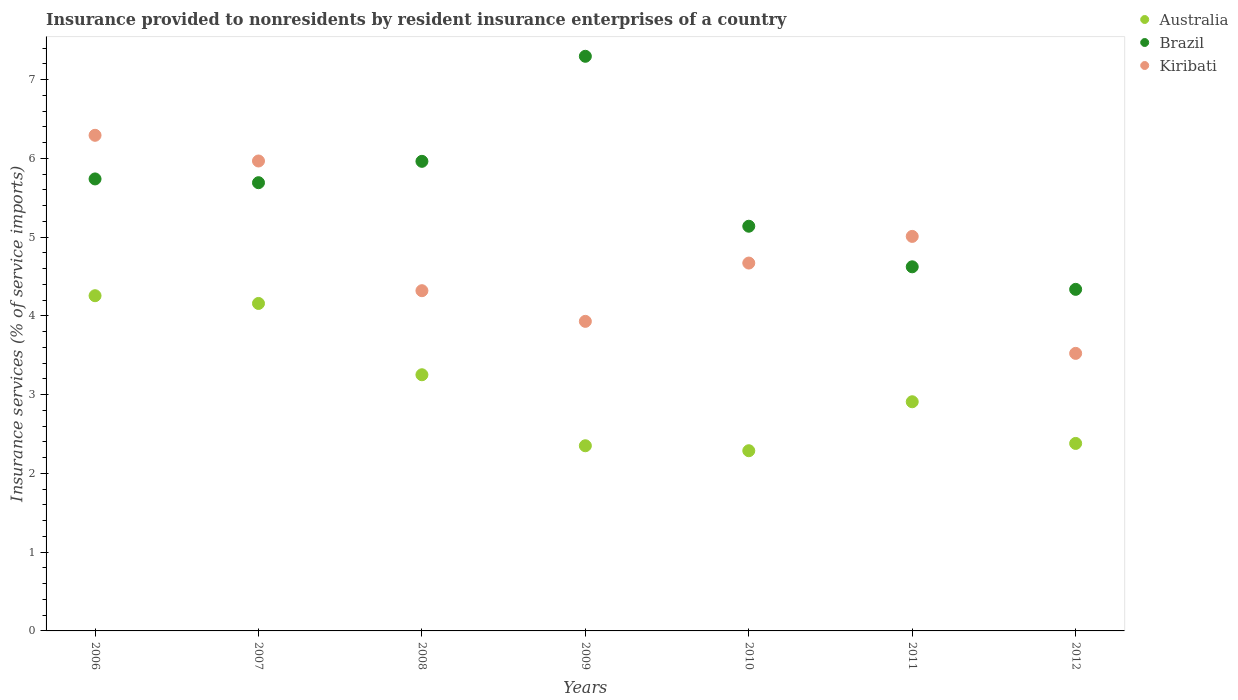How many different coloured dotlines are there?
Offer a terse response. 3. Is the number of dotlines equal to the number of legend labels?
Offer a terse response. Yes. What is the insurance provided to nonresidents in Brazil in 2010?
Offer a terse response. 5.14. Across all years, what is the maximum insurance provided to nonresidents in Brazil?
Provide a succinct answer. 7.3. Across all years, what is the minimum insurance provided to nonresidents in Brazil?
Your response must be concise. 4.34. In which year was the insurance provided to nonresidents in Brazil maximum?
Keep it short and to the point. 2009. In which year was the insurance provided to nonresidents in Kiribati minimum?
Give a very brief answer. 2012. What is the total insurance provided to nonresidents in Kiribati in the graph?
Offer a terse response. 33.71. What is the difference between the insurance provided to nonresidents in Australia in 2008 and that in 2009?
Offer a very short reply. 0.9. What is the difference between the insurance provided to nonresidents in Australia in 2006 and the insurance provided to nonresidents in Kiribati in 2007?
Your response must be concise. -1.71. What is the average insurance provided to nonresidents in Australia per year?
Your answer should be very brief. 3.08. In the year 2006, what is the difference between the insurance provided to nonresidents in Kiribati and insurance provided to nonresidents in Brazil?
Keep it short and to the point. 0.55. In how many years, is the insurance provided to nonresidents in Australia greater than 1.6 %?
Ensure brevity in your answer.  7. What is the ratio of the insurance provided to nonresidents in Brazil in 2006 to that in 2012?
Give a very brief answer. 1.32. Is the insurance provided to nonresidents in Kiribati in 2006 less than that in 2011?
Provide a succinct answer. No. Is the difference between the insurance provided to nonresidents in Kiribati in 2008 and 2010 greater than the difference between the insurance provided to nonresidents in Brazil in 2008 and 2010?
Offer a very short reply. No. What is the difference between the highest and the second highest insurance provided to nonresidents in Australia?
Your answer should be very brief. 0.1. What is the difference between the highest and the lowest insurance provided to nonresidents in Australia?
Ensure brevity in your answer.  1.97. In how many years, is the insurance provided to nonresidents in Australia greater than the average insurance provided to nonresidents in Australia taken over all years?
Your answer should be very brief. 3. Does the insurance provided to nonresidents in Kiribati monotonically increase over the years?
Provide a short and direct response. No. Is the insurance provided to nonresidents in Australia strictly less than the insurance provided to nonresidents in Kiribati over the years?
Your answer should be compact. Yes. How many years are there in the graph?
Provide a succinct answer. 7. What is the difference between two consecutive major ticks on the Y-axis?
Your answer should be compact. 1. Does the graph contain grids?
Provide a short and direct response. No. How many legend labels are there?
Make the answer very short. 3. How are the legend labels stacked?
Provide a short and direct response. Vertical. What is the title of the graph?
Ensure brevity in your answer.  Insurance provided to nonresidents by resident insurance enterprises of a country. Does "Tonga" appear as one of the legend labels in the graph?
Provide a short and direct response. No. What is the label or title of the X-axis?
Provide a succinct answer. Years. What is the label or title of the Y-axis?
Offer a terse response. Insurance services (% of service imports). What is the Insurance services (% of service imports) of Australia in 2006?
Make the answer very short. 4.26. What is the Insurance services (% of service imports) of Brazil in 2006?
Ensure brevity in your answer.  5.74. What is the Insurance services (% of service imports) in Kiribati in 2006?
Provide a short and direct response. 6.29. What is the Insurance services (% of service imports) of Australia in 2007?
Your response must be concise. 4.16. What is the Insurance services (% of service imports) in Brazil in 2007?
Offer a very short reply. 5.69. What is the Insurance services (% of service imports) of Kiribati in 2007?
Ensure brevity in your answer.  5.97. What is the Insurance services (% of service imports) of Australia in 2008?
Offer a very short reply. 3.25. What is the Insurance services (% of service imports) of Brazil in 2008?
Give a very brief answer. 5.96. What is the Insurance services (% of service imports) of Kiribati in 2008?
Keep it short and to the point. 4.32. What is the Insurance services (% of service imports) in Australia in 2009?
Ensure brevity in your answer.  2.35. What is the Insurance services (% of service imports) in Brazil in 2009?
Offer a very short reply. 7.3. What is the Insurance services (% of service imports) in Kiribati in 2009?
Provide a succinct answer. 3.93. What is the Insurance services (% of service imports) of Australia in 2010?
Make the answer very short. 2.29. What is the Insurance services (% of service imports) in Brazil in 2010?
Ensure brevity in your answer.  5.14. What is the Insurance services (% of service imports) of Kiribati in 2010?
Offer a very short reply. 4.67. What is the Insurance services (% of service imports) in Australia in 2011?
Offer a terse response. 2.91. What is the Insurance services (% of service imports) of Brazil in 2011?
Provide a short and direct response. 4.62. What is the Insurance services (% of service imports) of Kiribati in 2011?
Your answer should be very brief. 5.01. What is the Insurance services (% of service imports) in Australia in 2012?
Provide a short and direct response. 2.38. What is the Insurance services (% of service imports) in Brazil in 2012?
Give a very brief answer. 4.34. What is the Insurance services (% of service imports) in Kiribati in 2012?
Your answer should be very brief. 3.52. Across all years, what is the maximum Insurance services (% of service imports) in Australia?
Ensure brevity in your answer.  4.26. Across all years, what is the maximum Insurance services (% of service imports) in Brazil?
Give a very brief answer. 7.3. Across all years, what is the maximum Insurance services (% of service imports) in Kiribati?
Ensure brevity in your answer.  6.29. Across all years, what is the minimum Insurance services (% of service imports) in Australia?
Your answer should be compact. 2.29. Across all years, what is the minimum Insurance services (% of service imports) of Brazil?
Provide a succinct answer. 4.34. Across all years, what is the minimum Insurance services (% of service imports) in Kiribati?
Ensure brevity in your answer.  3.52. What is the total Insurance services (% of service imports) of Australia in the graph?
Give a very brief answer. 21.59. What is the total Insurance services (% of service imports) in Brazil in the graph?
Offer a terse response. 38.78. What is the total Insurance services (% of service imports) in Kiribati in the graph?
Your response must be concise. 33.71. What is the difference between the Insurance services (% of service imports) in Australia in 2006 and that in 2007?
Your response must be concise. 0.1. What is the difference between the Insurance services (% of service imports) in Brazil in 2006 and that in 2007?
Make the answer very short. 0.05. What is the difference between the Insurance services (% of service imports) in Kiribati in 2006 and that in 2007?
Offer a terse response. 0.33. What is the difference between the Insurance services (% of service imports) of Brazil in 2006 and that in 2008?
Offer a terse response. -0.22. What is the difference between the Insurance services (% of service imports) in Kiribati in 2006 and that in 2008?
Give a very brief answer. 1.97. What is the difference between the Insurance services (% of service imports) in Australia in 2006 and that in 2009?
Your response must be concise. 1.9. What is the difference between the Insurance services (% of service imports) of Brazil in 2006 and that in 2009?
Your answer should be very brief. -1.56. What is the difference between the Insurance services (% of service imports) of Kiribati in 2006 and that in 2009?
Your answer should be very brief. 2.36. What is the difference between the Insurance services (% of service imports) of Australia in 2006 and that in 2010?
Give a very brief answer. 1.97. What is the difference between the Insurance services (% of service imports) of Brazil in 2006 and that in 2010?
Your answer should be compact. 0.6. What is the difference between the Insurance services (% of service imports) of Kiribati in 2006 and that in 2010?
Your answer should be very brief. 1.62. What is the difference between the Insurance services (% of service imports) in Australia in 2006 and that in 2011?
Provide a short and direct response. 1.35. What is the difference between the Insurance services (% of service imports) in Brazil in 2006 and that in 2011?
Give a very brief answer. 1.12. What is the difference between the Insurance services (% of service imports) of Kiribati in 2006 and that in 2011?
Provide a succinct answer. 1.28. What is the difference between the Insurance services (% of service imports) of Australia in 2006 and that in 2012?
Ensure brevity in your answer.  1.88. What is the difference between the Insurance services (% of service imports) of Brazil in 2006 and that in 2012?
Your response must be concise. 1.4. What is the difference between the Insurance services (% of service imports) of Kiribati in 2006 and that in 2012?
Your answer should be compact. 2.77. What is the difference between the Insurance services (% of service imports) in Australia in 2007 and that in 2008?
Offer a very short reply. 0.91. What is the difference between the Insurance services (% of service imports) of Brazil in 2007 and that in 2008?
Provide a succinct answer. -0.27. What is the difference between the Insurance services (% of service imports) of Kiribati in 2007 and that in 2008?
Provide a short and direct response. 1.65. What is the difference between the Insurance services (% of service imports) in Australia in 2007 and that in 2009?
Offer a very short reply. 1.81. What is the difference between the Insurance services (% of service imports) in Brazil in 2007 and that in 2009?
Offer a terse response. -1.6. What is the difference between the Insurance services (% of service imports) of Kiribati in 2007 and that in 2009?
Provide a succinct answer. 2.04. What is the difference between the Insurance services (% of service imports) in Australia in 2007 and that in 2010?
Offer a very short reply. 1.87. What is the difference between the Insurance services (% of service imports) in Brazil in 2007 and that in 2010?
Offer a very short reply. 0.55. What is the difference between the Insurance services (% of service imports) in Kiribati in 2007 and that in 2010?
Your answer should be very brief. 1.3. What is the difference between the Insurance services (% of service imports) in Australia in 2007 and that in 2011?
Your answer should be compact. 1.25. What is the difference between the Insurance services (% of service imports) of Brazil in 2007 and that in 2011?
Give a very brief answer. 1.07. What is the difference between the Insurance services (% of service imports) in Kiribati in 2007 and that in 2011?
Offer a very short reply. 0.96. What is the difference between the Insurance services (% of service imports) of Australia in 2007 and that in 2012?
Offer a terse response. 1.78. What is the difference between the Insurance services (% of service imports) of Brazil in 2007 and that in 2012?
Make the answer very short. 1.35. What is the difference between the Insurance services (% of service imports) in Kiribati in 2007 and that in 2012?
Keep it short and to the point. 2.44. What is the difference between the Insurance services (% of service imports) in Australia in 2008 and that in 2009?
Keep it short and to the point. 0.9. What is the difference between the Insurance services (% of service imports) in Brazil in 2008 and that in 2009?
Make the answer very short. -1.33. What is the difference between the Insurance services (% of service imports) in Kiribati in 2008 and that in 2009?
Your answer should be very brief. 0.39. What is the difference between the Insurance services (% of service imports) in Australia in 2008 and that in 2010?
Ensure brevity in your answer.  0.96. What is the difference between the Insurance services (% of service imports) of Brazil in 2008 and that in 2010?
Ensure brevity in your answer.  0.82. What is the difference between the Insurance services (% of service imports) of Kiribati in 2008 and that in 2010?
Ensure brevity in your answer.  -0.35. What is the difference between the Insurance services (% of service imports) of Australia in 2008 and that in 2011?
Provide a short and direct response. 0.34. What is the difference between the Insurance services (% of service imports) in Brazil in 2008 and that in 2011?
Keep it short and to the point. 1.34. What is the difference between the Insurance services (% of service imports) in Kiribati in 2008 and that in 2011?
Keep it short and to the point. -0.69. What is the difference between the Insurance services (% of service imports) of Australia in 2008 and that in 2012?
Offer a terse response. 0.87. What is the difference between the Insurance services (% of service imports) of Brazil in 2008 and that in 2012?
Give a very brief answer. 1.63. What is the difference between the Insurance services (% of service imports) of Kiribati in 2008 and that in 2012?
Your answer should be very brief. 0.8. What is the difference between the Insurance services (% of service imports) of Australia in 2009 and that in 2010?
Keep it short and to the point. 0.06. What is the difference between the Insurance services (% of service imports) in Brazil in 2009 and that in 2010?
Your answer should be compact. 2.16. What is the difference between the Insurance services (% of service imports) of Kiribati in 2009 and that in 2010?
Offer a very short reply. -0.74. What is the difference between the Insurance services (% of service imports) in Australia in 2009 and that in 2011?
Your response must be concise. -0.56. What is the difference between the Insurance services (% of service imports) in Brazil in 2009 and that in 2011?
Your answer should be very brief. 2.67. What is the difference between the Insurance services (% of service imports) in Kiribati in 2009 and that in 2011?
Keep it short and to the point. -1.08. What is the difference between the Insurance services (% of service imports) in Australia in 2009 and that in 2012?
Make the answer very short. -0.03. What is the difference between the Insurance services (% of service imports) in Brazil in 2009 and that in 2012?
Make the answer very short. 2.96. What is the difference between the Insurance services (% of service imports) in Kiribati in 2009 and that in 2012?
Give a very brief answer. 0.41. What is the difference between the Insurance services (% of service imports) of Australia in 2010 and that in 2011?
Offer a terse response. -0.62. What is the difference between the Insurance services (% of service imports) in Brazil in 2010 and that in 2011?
Make the answer very short. 0.52. What is the difference between the Insurance services (% of service imports) in Kiribati in 2010 and that in 2011?
Your answer should be compact. -0.34. What is the difference between the Insurance services (% of service imports) in Australia in 2010 and that in 2012?
Keep it short and to the point. -0.09. What is the difference between the Insurance services (% of service imports) in Brazil in 2010 and that in 2012?
Provide a short and direct response. 0.8. What is the difference between the Insurance services (% of service imports) in Kiribati in 2010 and that in 2012?
Your answer should be compact. 1.15. What is the difference between the Insurance services (% of service imports) in Australia in 2011 and that in 2012?
Give a very brief answer. 0.53. What is the difference between the Insurance services (% of service imports) in Brazil in 2011 and that in 2012?
Provide a succinct answer. 0.29. What is the difference between the Insurance services (% of service imports) of Kiribati in 2011 and that in 2012?
Your response must be concise. 1.48. What is the difference between the Insurance services (% of service imports) of Australia in 2006 and the Insurance services (% of service imports) of Brazil in 2007?
Make the answer very short. -1.43. What is the difference between the Insurance services (% of service imports) of Australia in 2006 and the Insurance services (% of service imports) of Kiribati in 2007?
Your answer should be compact. -1.71. What is the difference between the Insurance services (% of service imports) of Brazil in 2006 and the Insurance services (% of service imports) of Kiribati in 2007?
Your answer should be very brief. -0.23. What is the difference between the Insurance services (% of service imports) in Australia in 2006 and the Insurance services (% of service imports) in Brazil in 2008?
Make the answer very short. -1.71. What is the difference between the Insurance services (% of service imports) of Australia in 2006 and the Insurance services (% of service imports) of Kiribati in 2008?
Keep it short and to the point. -0.06. What is the difference between the Insurance services (% of service imports) of Brazil in 2006 and the Insurance services (% of service imports) of Kiribati in 2008?
Your answer should be very brief. 1.42. What is the difference between the Insurance services (% of service imports) in Australia in 2006 and the Insurance services (% of service imports) in Brazil in 2009?
Keep it short and to the point. -3.04. What is the difference between the Insurance services (% of service imports) in Australia in 2006 and the Insurance services (% of service imports) in Kiribati in 2009?
Your answer should be compact. 0.33. What is the difference between the Insurance services (% of service imports) in Brazil in 2006 and the Insurance services (% of service imports) in Kiribati in 2009?
Give a very brief answer. 1.81. What is the difference between the Insurance services (% of service imports) of Australia in 2006 and the Insurance services (% of service imports) of Brazil in 2010?
Your answer should be compact. -0.88. What is the difference between the Insurance services (% of service imports) of Australia in 2006 and the Insurance services (% of service imports) of Kiribati in 2010?
Provide a succinct answer. -0.41. What is the difference between the Insurance services (% of service imports) of Brazil in 2006 and the Insurance services (% of service imports) of Kiribati in 2010?
Offer a terse response. 1.07. What is the difference between the Insurance services (% of service imports) of Australia in 2006 and the Insurance services (% of service imports) of Brazil in 2011?
Provide a short and direct response. -0.37. What is the difference between the Insurance services (% of service imports) in Australia in 2006 and the Insurance services (% of service imports) in Kiribati in 2011?
Give a very brief answer. -0.75. What is the difference between the Insurance services (% of service imports) of Brazil in 2006 and the Insurance services (% of service imports) of Kiribati in 2011?
Keep it short and to the point. 0.73. What is the difference between the Insurance services (% of service imports) in Australia in 2006 and the Insurance services (% of service imports) in Brazil in 2012?
Offer a very short reply. -0.08. What is the difference between the Insurance services (% of service imports) in Australia in 2006 and the Insurance services (% of service imports) in Kiribati in 2012?
Your answer should be compact. 0.73. What is the difference between the Insurance services (% of service imports) of Brazil in 2006 and the Insurance services (% of service imports) of Kiribati in 2012?
Offer a terse response. 2.21. What is the difference between the Insurance services (% of service imports) of Australia in 2007 and the Insurance services (% of service imports) of Brazil in 2008?
Give a very brief answer. -1.8. What is the difference between the Insurance services (% of service imports) in Australia in 2007 and the Insurance services (% of service imports) in Kiribati in 2008?
Offer a very short reply. -0.16. What is the difference between the Insurance services (% of service imports) of Brazil in 2007 and the Insurance services (% of service imports) of Kiribati in 2008?
Your response must be concise. 1.37. What is the difference between the Insurance services (% of service imports) of Australia in 2007 and the Insurance services (% of service imports) of Brazil in 2009?
Make the answer very short. -3.14. What is the difference between the Insurance services (% of service imports) in Australia in 2007 and the Insurance services (% of service imports) in Kiribati in 2009?
Ensure brevity in your answer.  0.23. What is the difference between the Insurance services (% of service imports) of Brazil in 2007 and the Insurance services (% of service imports) of Kiribati in 2009?
Make the answer very short. 1.76. What is the difference between the Insurance services (% of service imports) in Australia in 2007 and the Insurance services (% of service imports) in Brazil in 2010?
Provide a succinct answer. -0.98. What is the difference between the Insurance services (% of service imports) in Australia in 2007 and the Insurance services (% of service imports) in Kiribati in 2010?
Make the answer very short. -0.51. What is the difference between the Insurance services (% of service imports) in Brazil in 2007 and the Insurance services (% of service imports) in Kiribati in 2010?
Give a very brief answer. 1.02. What is the difference between the Insurance services (% of service imports) of Australia in 2007 and the Insurance services (% of service imports) of Brazil in 2011?
Make the answer very short. -0.47. What is the difference between the Insurance services (% of service imports) of Australia in 2007 and the Insurance services (% of service imports) of Kiribati in 2011?
Your answer should be compact. -0.85. What is the difference between the Insurance services (% of service imports) in Brazil in 2007 and the Insurance services (% of service imports) in Kiribati in 2011?
Your answer should be very brief. 0.68. What is the difference between the Insurance services (% of service imports) in Australia in 2007 and the Insurance services (% of service imports) in Brazil in 2012?
Ensure brevity in your answer.  -0.18. What is the difference between the Insurance services (% of service imports) in Australia in 2007 and the Insurance services (% of service imports) in Kiribati in 2012?
Provide a succinct answer. 0.63. What is the difference between the Insurance services (% of service imports) of Brazil in 2007 and the Insurance services (% of service imports) of Kiribati in 2012?
Your answer should be very brief. 2.17. What is the difference between the Insurance services (% of service imports) in Australia in 2008 and the Insurance services (% of service imports) in Brazil in 2009?
Your answer should be very brief. -4.04. What is the difference between the Insurance services (% of service imports) of Australia in 2008 and the Insurance services (% of service imports) of Kiribati in 2009?
Ensure brevity in your answer.  -0.68. What is the difference between the Insurance services (% of service imports) in Brazil in 2008 and the Insurance services (% of service imports) in Kiribati in 2009?
Keep it short and to the point. 2.03. What is the difference between the Insurance services (% of service imports) in Australia in 2008 and the Insurance services (% of service imports) in Brazil in 2010?
Ensure brevity in your answer.  -1.89. What is the difference between the Insurance services (% of service imports) of Australia in 2008 and the Insurance services (% of service imports) of Kiribati in 2010?
Offer a very short reply. -1.42. What is the difference between the Insurance services (% of service imports) of Brazil in 2008 and the Insurance services (% of service imports) of Kiribati in 2010?
Provide a short and direct response. 1.29. What is the difference between the Insurance services (% of service imports) in Australia in 2008 and the Insurance services (% of service imports) in Brazil in 2011?
Keep it short and to the point. -1.37. What is the difference between the Insurance services (% of service imports) of Australia in 2008 and the Insurance services (% of service imports) of Kiribati in 2011?
Offer a very short reply. -1.76. What is the difference between the Insurance services (% of service imports) of Brazil in 2008 and the Insurance services (% of service imports) of Kiribati in 2011?
Your answer should be compact. 0.95. What is the difference between the Insurance services (% of service imports) in Australia in 2008 and the Insurance services (% of service imports) in Brazil in 2012?
Make the answer very short. -1.08. What is the difference between the Insurance services (% of service imports) in Australia in 2008 and the Insurance services (% of service imports) in Kiribati in 2012?
Provide a succinct answer. -0.27. What is the difference between the Insurance services (% of service imports) of Brazil in 2008 and the Insurance services (% of service imports) of Kiribati in 2012?
Keep it short and to the point. 2.44. What is the difference between the Insurance services (% of service imports) of Australia in 2009 and the Insurance services (% of service imports) of Brazil in 2010?
Your answer should be compact. -2.79. What is the difference between the Insurance services (% of service imports) of Australia in 2009 and the Insurance services (% of service imports) of Kiribati in 2010?
Make the answer very short. -2.32. What is the difference between the Insurance services (% of service imports) of Brazil in 2009 and the Insurance services (% of service imports) of Kiribati in 2010?
Your answer should be very brief. 2.62. What is the difference between the Insurance services (% of service imports) of Australia in 2009 and the Insurance services (% of service imports) of Brazil in 2011?
Offer a terse response. -2.27. What is the difference between the Insurance services (% of service imports) of Australia in 2009 and the Insurance services (% of service imports) of Kiribati in 2011?
Keep it short and to the point. -2.66. What is the difference between the Insurance services (% of service imports) of Brazil in 2009 and the Insurance services (% of service imports) of Kiribati in 2011?
Offer a terse response. 2.29. What is the difference between the Insurance services (% of service imports) of Australia in 2009 and the Insurance services (% of service imports) of Brazil in 2012?
Provide a succinct answer. -1.99. What is the difference between the Insurance services (% of service imports) of Australia in 2009 and the Insurance services (% of service imports) of Kiribati in 2012?
Your response must be concise. -1.17. What is the difference between the Insurance services (% of service imports) of Brazil in 2009 and the Insurance services (% of service imports) of Kiribati in 2012?
Your response must be concise. 3.77. What is the difference between the Insurance services (% of service imports) in Australia in 2010 and the Insurance services (% of service imports) in Brazil in 2011?
Give a very brief answer. -2.33. What is the difference between the Insurance services (% of service imports) in Australia in 2010 and the Insurance services (% of service imports) in Kiribati in 2011?
Keep it short and to the point. -2.72. What is the difference between the Insurance services (% of service imports) in Brazil in 2010 and the Insurance services (% of service imports) in Kiribati in 2011?
Provide a short and direct response. 0.13. What is the difference between the Insurance services (% of service imports) in Australia in 2010 and the Insurance services (% of service imports) in Brazil in 2012?
Your answer should be very brief. -2.05. What is the difference between the Insurance services (% of service imports) in Australia in 2010 and the Insurance services (% of service imports) in Kiribati in 2012?
Make the answer very short. -1.24. What is the difference between the Insurance services (% of service imports) of Brazil in 2010 and the Insurance services (% of service imports) of Kiribati in 2012?
Your answer should be compact. 1.61. What is the difference between the Insurance services (% of service imports) of Australia in 2011 and the Insurance services (% of service imports) of Brazil in 2012?
Keep it short and to the point. -1.43. What is the difference between the Insurance services (% of service imports) in Australia in 2011 and the Insurance services (% of service imports) in Kiribati in 2012?
Keep it short and to the point. -0.61. What is the difference between the Insurance services (% of service imports) in Brazil in 2011 and the Insurance services (% of service imports) in Kiribati in 2012?
Provide a short and direct response. 1.1. What is the average Insurance services (% of service imports) in Australia per year?
Offer a very short reply. 3.08. What is the average Insurance services (% of service imports) in Brazil per year?
Your answer should be compact. 5.54. What is the average Insurance services (% of service imports) in Kiribati per year?
Ensure brevity in your answer.  4.82. In the year 2006, what is the difference between the Insurance services (% of service imports) in Australia and Insurance services (% of service imports) in Brazil?
Your answer should be compact. -1.48. In the year 2006, what is the difference between the Insurance services (% of service imports) of Australia and Insurance services (% of service imports) of Kiribati?
Offer a very short reply. -2.04. In the year 2006, what is the difference between the Insurance services (% of service imports) of Brazil and Insurance services (% of service imports) of Kiribati?
Keep it short and to the point. -0.55. In the year 2007, what is the difference between the Insurance services (% of service imports) of Australia and Insurance services (% of service imports) of Brazil?
Your answer should be compact. -1.53. In the year 2007, what is the difference between the Insurance services (% of service imports) of Australia and Insurance services (% of service imports) of Kiribati?
Your answer should be compact. -1.81. In the year 2007, what is the difference between the Insurance services (% of service imports) of Brazil and Insurance services (% of service imports) of Kiribati?
Offer a terse response. -0.28. In the year 2008, what is the difference between the Insurance services (% of service imports) in Australia and Insurance services (% of service imports) in Brazil?
Ensure brevity in your answer.  -2.71. In the year 2008, what is the difference between the Insurance services (% of service imports) of Australia and Insurance services (% of service imports) of Kiribati?
Ensure brevity in your answer.  -1.07. In the year 2008, what is the difference between the Insurance services (% of service imports) in Brazil and Insurance services (% of service imports) in Kiribati?
Give a very brief answer. 1.64. In the year 2009, what is the difference between the Insurance services (% of service imports) in Australia and Insurance services (% of service imports) in Brazil?
Offer a terse response. -4.94. In the year 2009, what is the difference between the Insurance services (% of service imports) in Australia and Insurance services (% of service imports) in Kiribati?
Provide a short and direct response. -1.58. In the year 2009, what is the difference between the Insurance services (% of service imports) in Brazil and Insurance services (% of service imports) in Kiribati?
Give a very brief answer. 3.37. In the year 2010, what is the difference between the Insurance services (% of service imports) of Australia and Insurance services (% of service imports) of Brazil?
Your response must be concise. -2.85. In the year 2010, what is the difference between the Insurance services (% of service imports) in Australia and Insurance services (% of service imports) in Kiribati?
Your response must be concise. -2.38. In the year 2010, what is the difference between the Insurance services (% of service imports) of Brazil and Insurance services (% of service imports) of Kiribati?
Offer a terse response. 0.47. In the year 2011, what is the difference between the Insurance services (% of service imports) of Australia and Insurance services (% of service imports) of Brazil?
Keep it short and to the point. -1.71. In the year 2011, what is the difference between the Insurance services (% of service imports) in Australia and Insurance services (% of service imports) in Kiribati?
Offer a very short reply. -2.1. In the year 2011, what is the difference between the Insurance services (% of service imports) in Brazil and Insurance services (% of service imports) in Kiribati?
Your response must be concise. -0.39. In the year 2012, what is the difference between the Insurance services (% of service imports) in Australia and Insurance services (% of service imports) in Brazil?
Keep it short and to the point. -1.96. In the year 2012, what is the difference between the Insurance services (% of service imports) in Australia and Insurance services (% of service imports) in Kiribati?
Make the answer very short. -1.14. In the year 2012, what is the difference between the Insurance services (% of service imports) of Brazil and Insurance services (% of service imports) of Kiribati?
Your answer should be compact. 0.81. What is the ratio of the Insurance services (% of service imports) of Australia in 2006 to that in 2007?
Give a very brief answer. 1.02. What is the ratio of the Insurance services (% of service imports) in Brazil in 2006 to that in 2007?
Your answer should be compact. 1.01. What is the ratio of the Insurance services (% of service imports) in Kiribati in 2006 to that in 2007?
Make the answer very short. 1.05. What is the ratio of the Insurance services (% of service imports) in Australia in 2006 to that in 2008?
Offer a very short reply. 1.31. What is the ratio of the Insurance services (% of service imports) of Brazil in 2006 to that in 2008?
Offer a very short reply. 0.96. What is the ratio of the Insurance services (% of service imports) in Kiribati in 2006 to that in 2008?
Your answer should be very brief. 1.46. What is the ratio of the Insurance services (% of service imports) of Australia in 2006 to that in 2009?
Ensure brevity in your answer.  1.81. What is the ratio of the Insurance services (% of service imports) of Brazil in 2006 to that in 2009?
Offer a very short reply. 0.79. What is the ratio of the Insurance services (% of service imports) of Kiribati in 2006 to that in 2009?
Your response must be concise. 1.6. What is the ratio of the Insurance services (% of service imports) in Australia in 2006 to that in 2010?
Provide a short and direct response. 1.86. What is the ratio of the Insurance services (% of service imports) of Brazil in 2006 to that in 2010?
Your answer should be compact. 1.12. What is the ratio of the Insurance services (% of service imports) in Kiribati in 2006 to that in 2010?
Give a very brief answer. 1.35. What is the ratio of the Insurance services (% of service imports) of Australia in 2006 to that in 2011?
Your response must be concise. 1.46. What is the ratio of the Insurance services (% of service imports) in Brazil in 2006 to that in 2011?
Your answer should be very brief. 1.24. What is the ratio of the Insurance services (% of service imports) in Kiribati in 2006 to that in 2011?
Provide a short and direct response. 1.26. What is the ratio of the Insurance services (% of service imports) in Australia in 2006 to that in 2012?
Your answer should be very brief. 1.79. What is the ratio of the Insurance services (% of service imports) of Brazil in 2006 to that in 2012?
Offer a terse response. 1.32. What is the ratio of the Insurance services (% of service imports) in Kiribati in 2006 to that in 2012?
Your answer should be very brief. 1.79. What is the ratio of the Insurance services (% of service imports) in Australia in 2007 to that in 2008?
Your answer should be compact. 1.28. What is the ratio of the Insurance services (% of service imports) in Brazil in 2007 to that in 2008?
Your answer should be compact. 0.95. What is the ratio of the Insurance services (% of service imports) of Kiribati in 2007 to that in 2008?
Your answer should be compact. 1.38. What is the ratio of the Insurance services (% of service imports) of Australia in 2007 to that in 2009?
Make the answer very short. 1.77. What is the ratio of the Insurance services (% of service imports) in Brazil in 2007 to that in 2009?
Provide a short and direct response. 0.78. What is the ratio of the Insurance services (% of service imports) in Kiribati in 2007 to that in 2009?
Provide a succinct answer. 1.52. What is the ratio of the Insurance services (% of service imports) of Australia in 2007 to that in 2010?
Keep it short and to the point. 1.82. What is the ratio of the Insurance services (% of service imports) of Brazil in 2007 to that in 2010?
Keep it short and to the point. 1.11. What is the ratio of the Insurance services (% of service imports) in Kiribati in 2007 to that in 2010?
Your response must be concise. 1.28. What is the ratio of the Insurance services (% of service imports) in Australia in 2007 to that in 2011?
Your response must be concise. 1.43. What is the ratio of the Insurance services (% of service imports) in Brazil in 2007 to that in 2011?
Your answer should be compact. 1.23. What is the ratio of the Insurance services (% of service imports) in Kiribati in 2007 to that in 2011?
Give a very brief answer. 1.19. What is the ratio of the Insurance services (% of service imports) in Australia in 2007 to that in 2012?
Make the answer very short. 1.75. What is the ratio of the Insurance services (% of service imports) in Brazil in 2007 to that in 2012?
Your response must be concise. 1.31. What is the ratio of the Insurance services (% of service imports) of Kiribati in 2007 to that in 2012?
Provide a short and direct response. 1.69. What is the ratio of the Insurance services (% of service imports) of Australia in 2008 to that in 2009?
Your answer should be very brief. 1.38. What is the ratio of the Insurance services (% of service imports) in Brazil in 2008 to that in 2009?
Your answer should be very brief. 0.82. What is the ratio of the Insurance services (% of service imports) of Kiribati in 2008 to that in 2009?
Offer a very short reply. 1.1. What is the ratio of the Insurance services (% of service imports) of Australia in 2008 to that in 2010?
Give a very brief answer. 1.42. What is the ratio of the Insurance services (% of service imports) in Brazil in 2008 to that in 2010?
Ensure brevity in your answer.  1.16. What is the ratio of the Insurance services (% of service imports) in Kiribati in 2008 to that in 2010?
Your response must be concise. 0.92. What is the ratio of the Insurance services (% of service imports) of Australia in 2008 to that in 2011?
Provide a succinct answer. 1.12. What is the ratio of the Insurance services (% of service imports) of Brazil in 2008 to that in 2011?
Keep it short and to the point. 1.29. What is the ratio of the Insurance services (% of service imports) in Kiribati in 2008 to that in 2011?
Offer a very short reply. 0.86. What is the ratio of the Insurance services (% of service imports) in Australia in 2008 to that in 2012?
Provide a succinct answer. 1.37. What is the ratio of the Insurance services (% of service imports) in Brazil in 2008 to that in 2012?
Provide a succinct answer. 1.37. What is the ratio of the Insurance services (% of service imports) in Kiribati in 2008 to that in 2012?
Your answer should be very brief. 1.23. What is the ratio of the Insurance services (% of service imports) of Australia in 2009 to that in 2010?
Provide a succinct answer. 1.03. What is the ratio of the Insurance services (% of service imports) of Brazil in 2009 to that in 2010?
Offer a terse response. 1.42. What is the ratio of the Insurance services (% of service imports) of Kiribati in 2009 to that in 2010?
Your answer should be compact. 0.84. What is the ratio of the Insurance services (% of service imports) of Australia in 2009 to that in 2011?
Your answer should be very brief. 0.81. What is the ratio of the Insurance services (% of service imports) of Brazil in 2009 to that in 2011?
Keep it short and to the point. 1.58. What is the ratio of the Insurance services (% of service imports) in Kiribati in 2009 to that in 2011?
Provide a short and direct response. 0.78. What is the ratio of the Insurance services (% of service imports) of Australia in 2009 to that in 2012?
Provide a succinct answer. 0.99. What is the ratio of the Insurance services (% of service imports) in Brazil in 2009 to that in 2012?
Make the answer very short. 1.68. What is the ratio of the Insurance services (% of service imports) in Kiribati in 2009 to that in 2012?
Provide a succinct answer. 1.12. What is the ratio of the Insurance services (% of service imports) of Australia in 2010 to that in 2011?
Give a very brief answer. 0.79. What is the ratio of the Insurance services (% of service imports) of Brazil in 2010 to that in 2011?
Ensure brevity in your answer.  1.11. What is the ratio of the Insurance services (% of service imports) in Kiribati in 2010 to that in 2011?
Your answer should be compact. 0.93. What is the ratio of the Insurance services (% of service imports) of Australia in 2010 to that in 2012?
Offer a very short reply. 0.96. What is the ratio of the Insurance services (% of service imports) of Brazil in 2010 to that in 2012?
Your response must be concise. 1.18. What is the ratio of the Insurance services (% of service imports) in Kiribati in 2010 to that in 2012?
Your answer should be very brief. 1.33. What is the ratio of the Insurance services (% of service imports) in Australia in 2011 to that in 2012?
Keep it short and to the point. 1.22. What is the ratio of the Insurance services (% of service imports) of Brazil in 2011 to that in 2012?
Keep it short and to the point. 1.07. What is the ratio of the Insurance services (% of service imports) in Kiribati in 2011 to that in 2012?
Offer a very short reply. 1.42. What is the difference between the highest and the second highest Insurance services (% of service imports) of Australia?
Make the answer very short. 0.1. What is the difference between the highest and the second highest Insurance services (% of service imports) in Brazil?
Your answer should be compact. 1.33. What is the difference between the highest and the second highest Insurance services (% of service imports) of Kiribati?
Keep it short and to the point. 0.33. What is the difference between the highest and the lowest Insurance services (% of service imports) of Australia?
Provide a succinct answer. 1.97. What is the difference between the highest and the lowest Insurance services (% of service imports) in Brazil?
Ensure brevity in your answer.  2.96. What is the difference between the highest and the lowest Insurance services (% of service imports) of Kiribati?
Offer a very short reply. 2.77. 